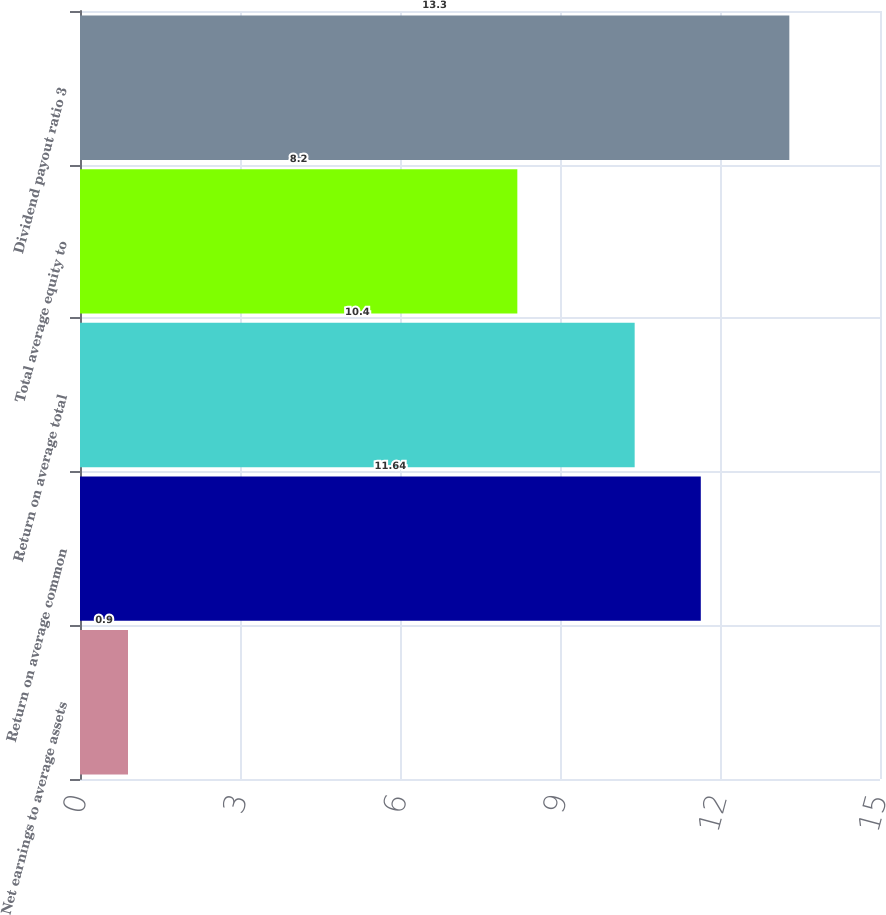Convert chart. <chart><loc_0><loc_0><loc_500><loc_500><bar_chart><fcel>Net earnings to average assets<fcel>Return on average common<fcel>Return on average total<fcel>Total average equity to<fcel>Dividend payout ratio 3<nl><fcel>0.9<fcel>11.64<fcel>10.4<fcel>8.2<fcel>13.3<nl></chart> 